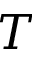<formula> <loc_0><loc_0><loc_500><loc_500>T</formula> 